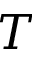<formula> <loc_0><loc_0><loc_500><loc_500>T</formula> 